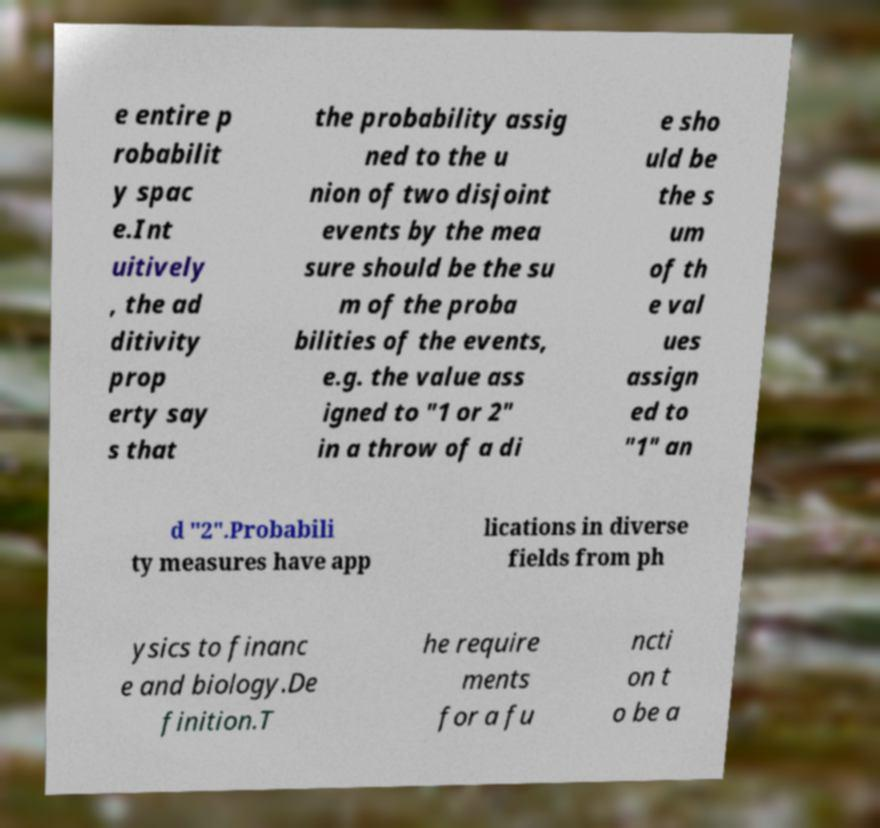There's text embedded in this image that I need extracted. Can you transcribe it verbatim? e entire p robabilit y spac e.Int uitively , the ad ditivity prop erty say s that the probability assig ned to the u nion of two disjoint events by the mea sure should be the su m of the proba bilities of the events, e.g. the value ass igned to "1 or 2" in a throw of a di e sho uld be the s um of th e val ues assign ed to "1" an d "2".Probabili ty measures have app lications in diverse fields from ph ysics to financ e and biology.De finition.T he require ments for a fu ncti on t o be a 